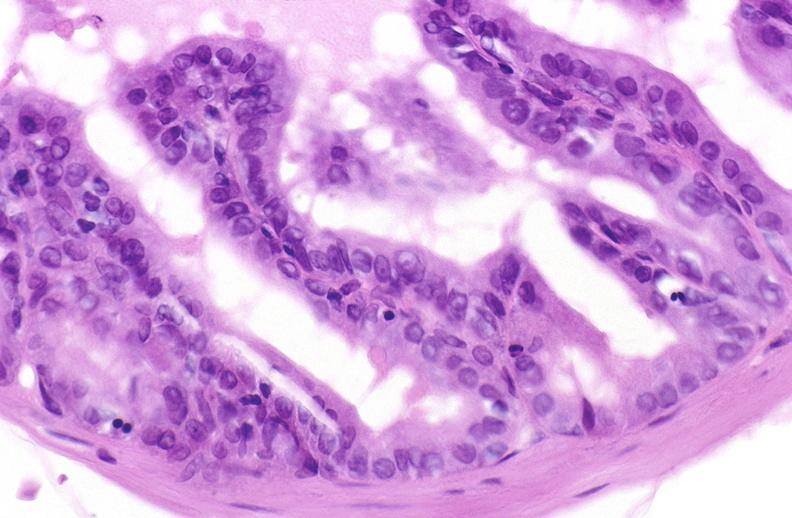when does this image show apoptosis in prostate?
Answer the question using a single word or phrase. After orchiectomy 